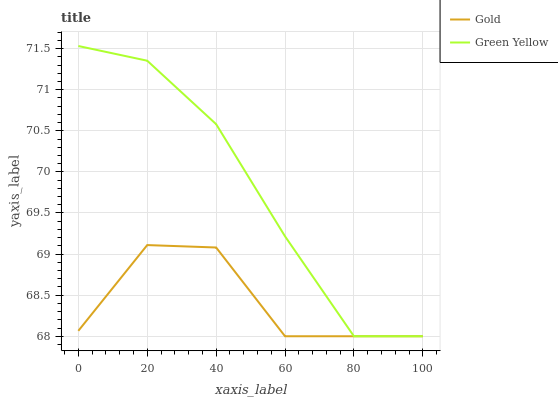Does Gold have the minimum area under the curve?
Answer yes or no. Yes. Does Green Yellow have the maximum area under the curve?
Answer yes or no. Yes. Does Gold have the maximum area under the curve?
Answer yes or no. No. Is Green Yellow the smoothest?
Answer yes or no. Yes. Is Gold the roughest?
Answer yes or no. Yes. Is Gold the smoothest?
Answer yes or no. No. Does Green Yellow have the lowest value?
Answer yes or no. Yes. Does Green Yellow have the highest value?
Answer yes or no. Yes. Does Gold have the highest value?
Answer yes or no. No. Does Green Yellow intersect Gold?
Answer yes or no. Yes. Is Green Yellow less than Gold?
Answer yes or no. No. Is Green Yellow greater than Gold?
Answer yes or no. No. 